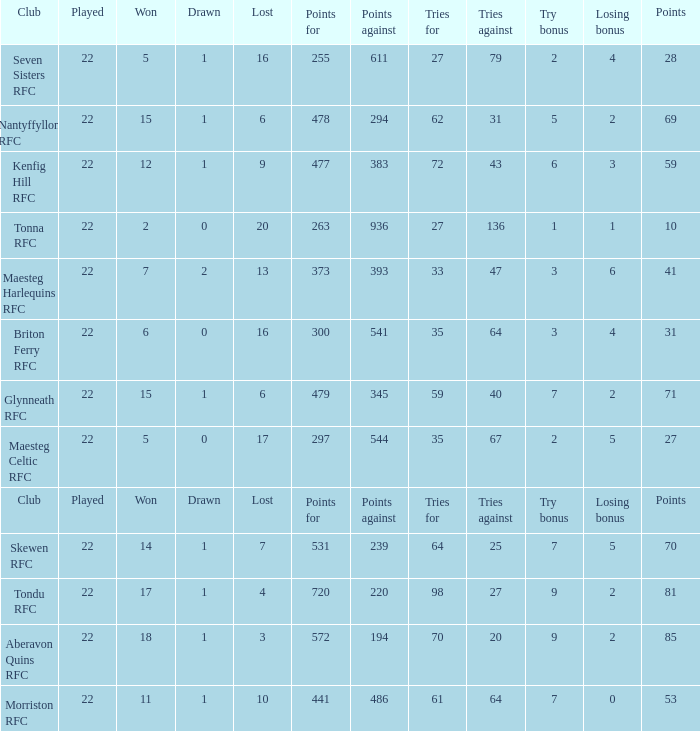How many tries against got the club with 62 tries for? 31.0. 